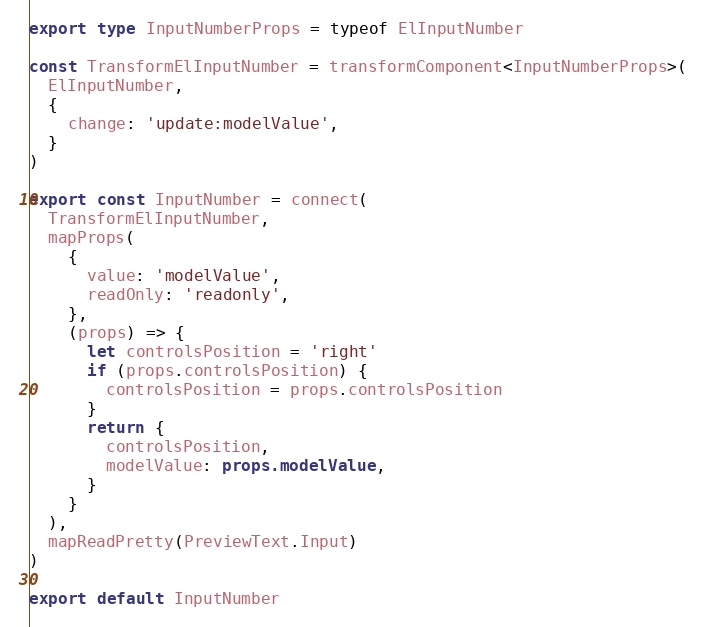Convert code to text. <code><loc_0><loc_0><loc_500><loc_500><_TypeScript_>
export type InputNumberProps = typeof ElInputNumber

const TransformElInputNumber = transformComponent<InputNumberProps>(
  ElInputNumber,
  {
    change: 'update:modelValue',
  }
)

export const InputNumber = connect(
  TransformElInputNumber,
  mapProps(
    {
      value: 'modelValue',
      readOnly: 'readonly',
    },
    (props) => {
      let controlsPosition = 'right'
      if (props.controlsPosition) {
        controlsPosition = props.controlsPosition
      }
      return {
        controlsPosition,
        modelValue: props.modelValue,
      }
    }
  ),
  mapReadPretty(PreviewText.Input)
)

export default InputNumber
</code> 